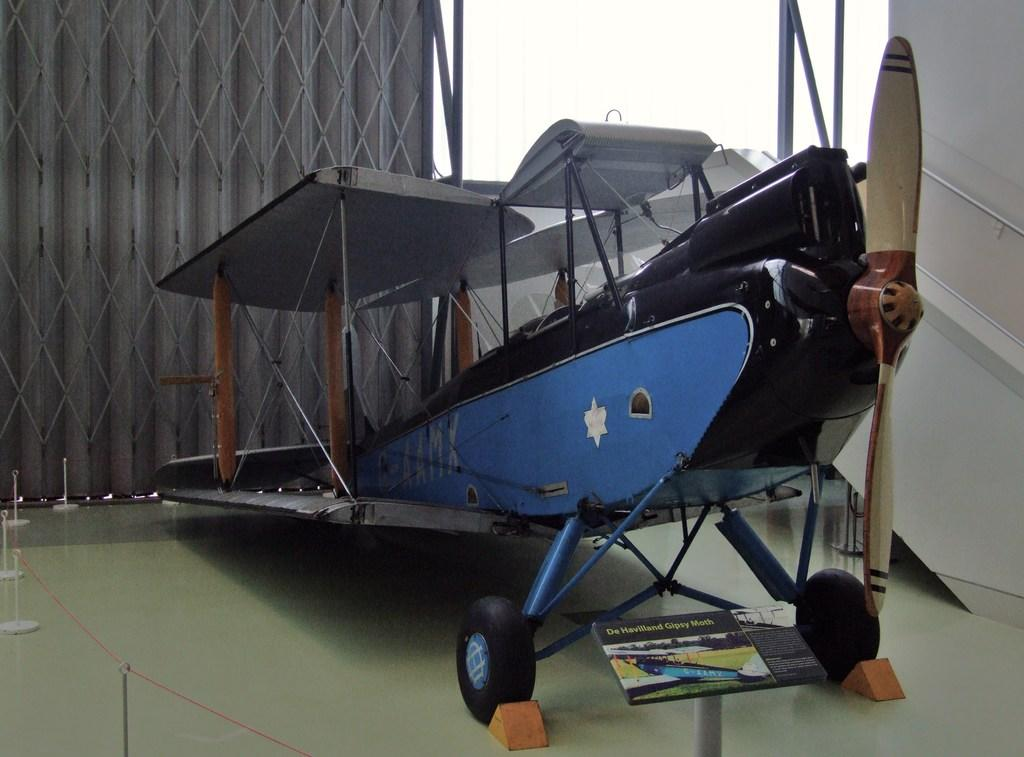What is the main subject of the picture? The main subject of the picture is an aircraft. What is located at the bottom of the picture? There is a board at the bottom of the picture. What can be seen on the left side of the picture? There is a thread on the left side of the picture. What part of the aircraft is visible on the right side of the picture? The propeller of the aircraft is visible on the right side of the picture. How far away is the manager from the aircraft in the image? There is no manager present in the image, so it is not possible to determine the distance between them. 